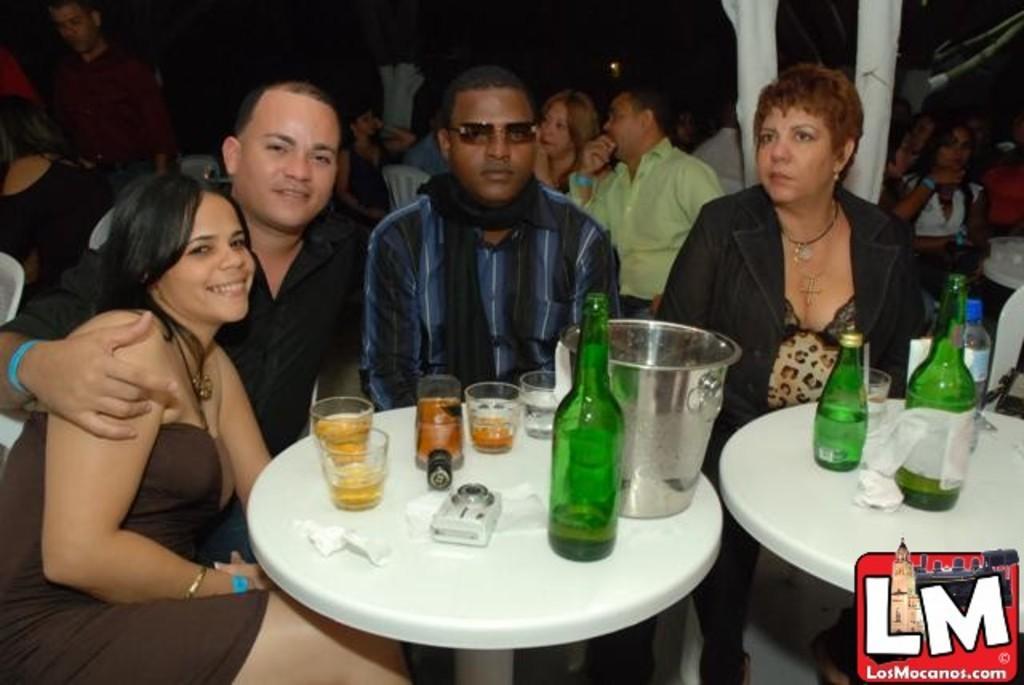Can you describe this image briefly? In this image I can see four people are sitting in-front of the table. On the table there is a bottle and the glasses. In the background there are few more people sitting. 